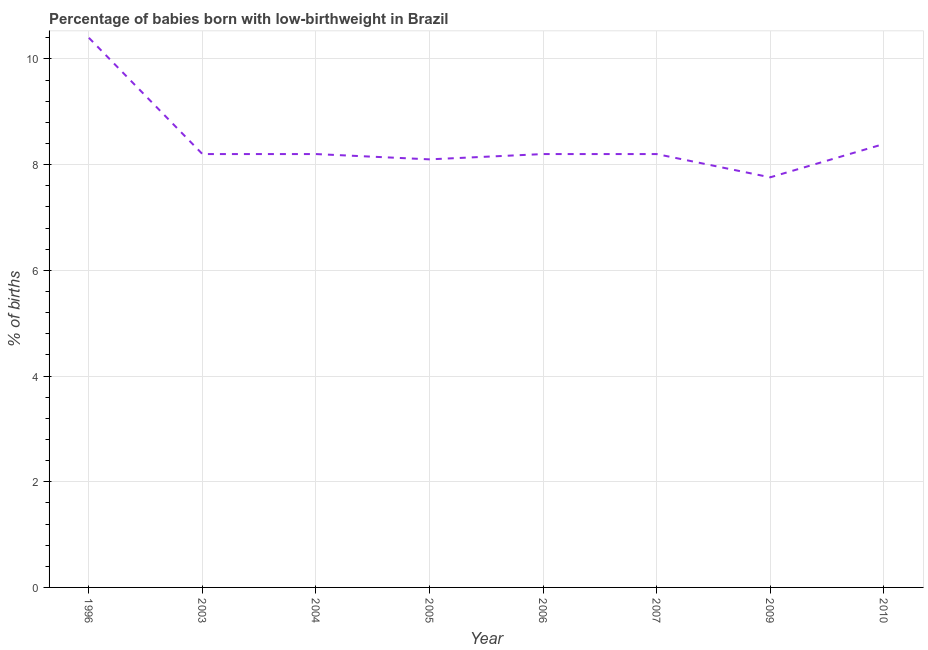What is the percentage of babies who were born with low-birthweight in 2010?
Your response must be concise. 8.39. Across all years, what is the minimum percentage of babies who were born with low-birthweight?
Offer a very short reply. 7.76. In which year was the percentage of babies who were born with low-birthweight minimum?
Offer a very short reply. 2009. What is the sum of the percentage of babies who were born with low-birthweight?
Give a very brief answer. 67.45. What is the difference between the percentage of babies who were born with low-birthweight in 2003 and 2010?
Your answer should be compact. -0.19. What is the average percentage of babies who were born with low-birthweight per year?
Offer a very short reply. 8.43. What is the median percentage of babies who were born with low-birthweight?
Give a very brief answer. 8.2. In how many years, is the percentage of babies who were born with low-birthweight greater than 8 %?
Offer a very short reply. 7. What is the ratio of the percentage of babies who were born with low-birthweight in 2007 to that in 2009?
Provide a succinct answer. 1.06. Is the difference between the percentage of babies who were born with low-birthweight in 2004 and 2007 greater than the difference between any two years?
Keep it short and to the point. No. What is the difference between the highest and the second highest percentage of babies who were born with low-birthweight?
Your answer should be very brief. 2.01. What is the difference between the highest and the lowest percentage of babies who were born with low-birthweight?
Offer a very short reply. 2.64. In how many years, is the percentage of babies who were born with low-birthweight greater than the average percentage of babies who were born with low-birthweight taken over all years?
Provide a succinct answer. 1. Does the percentage of babies who were born with low-birthweight monotonically increase over the years?
Keep it short and to the point. No. How many lines are there?
Provide a succinct answer. 1. What is the difference between two consecutive major ticks on the Y-axis?
Offer a very short reply. 2. Are the values on the major ticks of Y-axis written in scientific E-notation?
Your answer should be very brief. No. Does the graph contain grids?
Keep it short and to the point. Yes. What is the title of the graph?
Your answer should be very brief. Percentage of babies born with low-birthweight in Brazil. What is the label or title of the Y-axis?
Ensure brevity in your answer.  % of births. What is the % of births in 2005?
Your answer should be compact. 8.1. What is the % of births in 2009?
Your response must be concise. 7.76. What is the % of births in 2010?
Keep it short and to the point. 8.39. What is the difference between the % of births in 1996 and 2005?
Provide a succinct answer. 2.3. What is the difference between the % of births in 1996 and 2007?
Ensure brevity in your answer.  2.2. What is the difference between the % of births in 1996 and 2009?
Your response must be concise. 2.64. What is the difference between the % of births in 1996 and 2010?
Your answer should be very brief. 2.01. What is the difference between the % of births in 2003 and 2005?
Offer a terse response. 0.1. What is the difference between the % of births in 2003 and 2006?
Ensure brevity in your answer.  0. What is the difference between the % of births in 2003 and 2009?
Offer a very short reply. 0.44. What is the difference between the % of births in 2003 and 2010?
Provide a succinct answer. -0.19. What is the difference between the % of births in 2004 and 2007?
Offer a terse response. 0. What is the difference between the % of births in 2004 and 2009?
Keep it short and to the point. 0.44. What is the difference between the % of births in 2004 and 2010?
Ensure brevity in your answer.  -0.19. What is the difference between the % of births in 2005 and 2007?
Offer a terse response. -0.1. What is the difference between the % of births in 2005 and 2009?
Offer a terse response. 0.34. What is the difference between the % of births in 2005 and 2010?
Ensure brevity in your answer.  -0.29. What is the difference between the % of births in 2006 and 2007?
Provide a short and direct response. 0. What is the difference between the % of births in 2006 and 2009?
Your answer should be compact. 0.44. What is the difference between the % of births in 2006 and 2010?
Your response must be concise. -0.19. What is the difference between the % of births in 2007 and 2009?
Provide a short and direct response. 0.44. What is the difference between the % of births in 2007 and 2010?
Give a very brief answer. -0.19. What is the difference between the % of births in 2009 and 2010?
Ensure brevity in your answer.  -0.63. What is the ratio of the % of births in 1996 to that in 2003?
Offer a terse response. 1.27. What is the ratio of the % of births in 1996 to that in 2004?
Provide a succinct answer. 1.27. What is the ratio of the % of births in 1996 to that in 2005?
Offer a very short reply. 1.28. What is the ratio of the % of births in 1996 to that in 2006?
Provide a succinct answer. 1.27. What is the ratio of the % of births in 1996 to that in 2007?
Your answer should be very brief. 1.27. What is the ratio of the % of births in 1996 to that in 2009?
Your answer should be very brief. 1.34. What is the ratio of the % of births in 1996 to that in 2010?
Your answer should be compact. 1.24. What is the ratio of the % of births in 2003 to that in 2004?
Provide a succinct answer. 1. What is the ratio of the % of births in 2003 to that in 2009?
Your response must be concise. 1.06. What is the ratio of the % of births in 2004 to that in 2005?
Make the answer very short. 1.01. What is the ratio of the % of births in 2004 to that in 2009?
Make the answer very short. 1.06. What is the ratio of the % of births in 2004 to that in 2010?
Keep it short and to the point. 0.98. What is the ratio of the % of births in 2005 to that in 2006?
Ensure brevity in your answer.  0.99. What is the ratio of the % of births in 2005 to that in 2007?
Make the answer very short. 0.99. What is the ratio of the % of births in 2005 to that in 2009?
Give a very brief answer. 1.04. What is the ratio of the % of births in 2005 to that in 2010?
Give a very brief answer. 0.96. What is the ratio of the % of births in 2006 to that in 2007?
Offer a terse response. 1. What is the ratio of the % of births in 2006 to that in 2009?
Make the answer very short. 1.06. What is the ratio of the % of births in 2006 to that in 2010?
Keep it short and to the point. 0.98. What is the ratio of the % of births in 2007 to that in 2009?
Give a very brief answer. 1.06. What is the ratio of the % of births in 2007 to that in 2010?
Your answer should be very brief. 0.98. What is the ratio of the % of births in 2009 to that in 2010?
Keep it short and to the point. 0.93. 